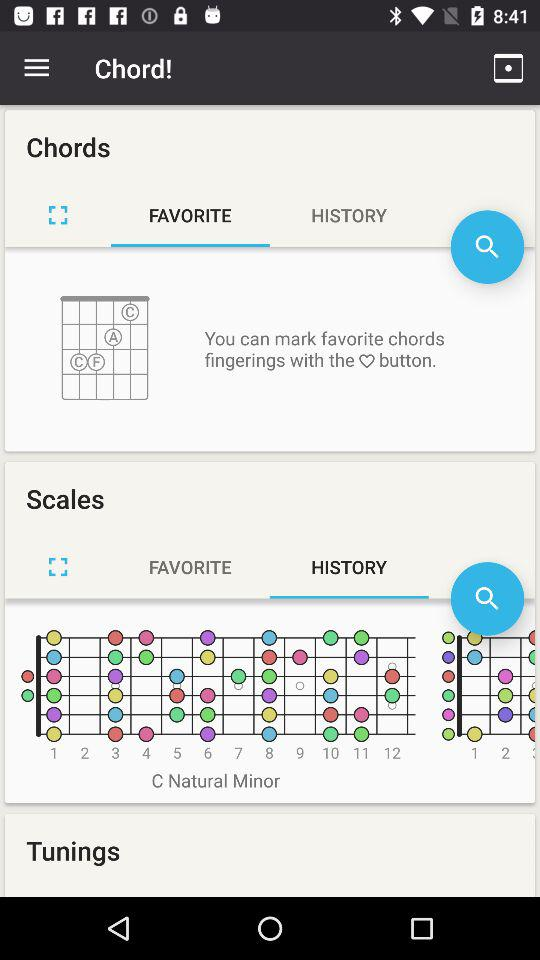What is the application name? The application name is "Chord!". 